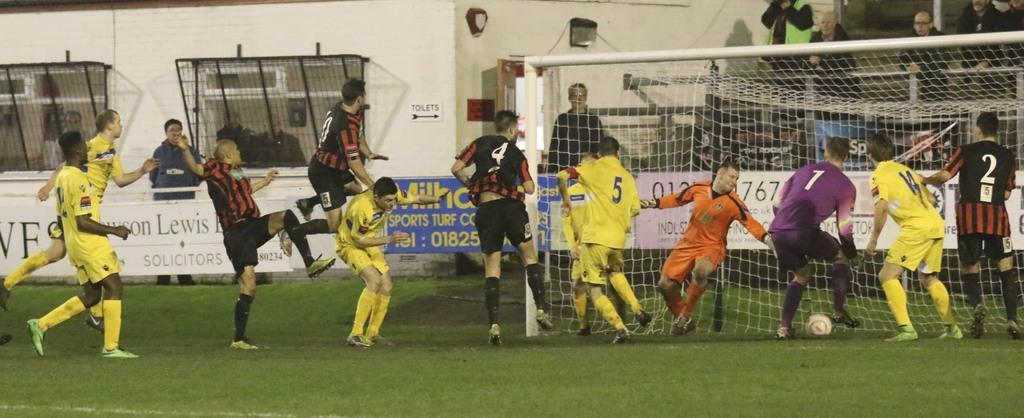<image>
Share a concise interpretation of the image provided. soccer game with partially obscured sponsor signs for lewis solicitors and sports turf 